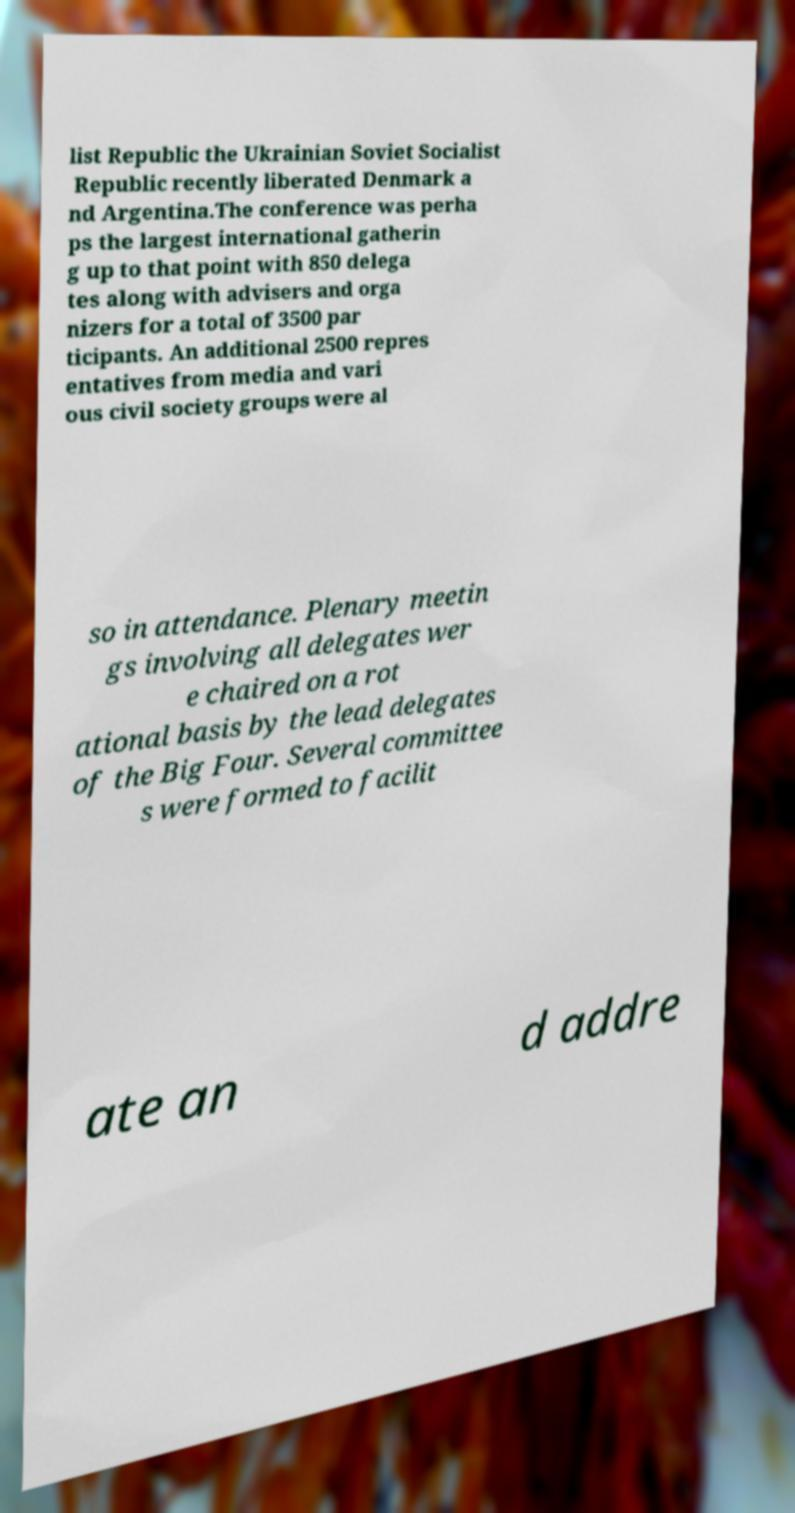For documentation purposes, I need the text within this image transcribed. Could you provide that? list Republic the Ukrainian Soviet Socialist Republic recently liberated Denmark a nd Argentina.The conference was perha ps the largest international gatherin g up to that point with 850 delega tes along with advisers and orga nizers for a total of 3500 par ticipants. An additional 2500 repres entatives from media and vari ous civil society groups were al so in attendance. Plenary meetin gs involving all delegates wer e chaired on a rot ational basis by the lead delegates of the Big Four. Several committee s were formed to facilit ate an d addre 